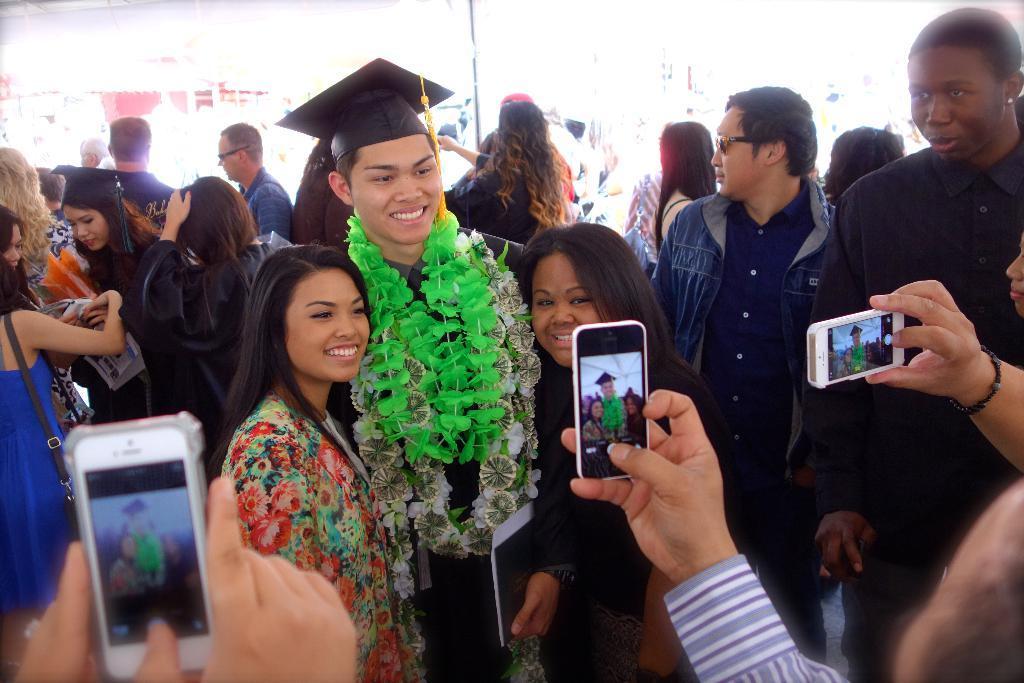Could you give a brief overview of what you see in this image? This Image is clicked in a graduation function, there are so many people, so many are clicking pictures. Some people are with graduation dress, garlands. 